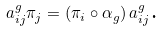Convert formula to latex. <formula><loc_0><loc_0><loc_500><loc_500>a _ { i j } ^ { g } \pi _ { j } = \left ( \pi _ { i } \circ \alpha _ { g } \right ) a _ { i j } ^ { g } \text {.}</formula> 